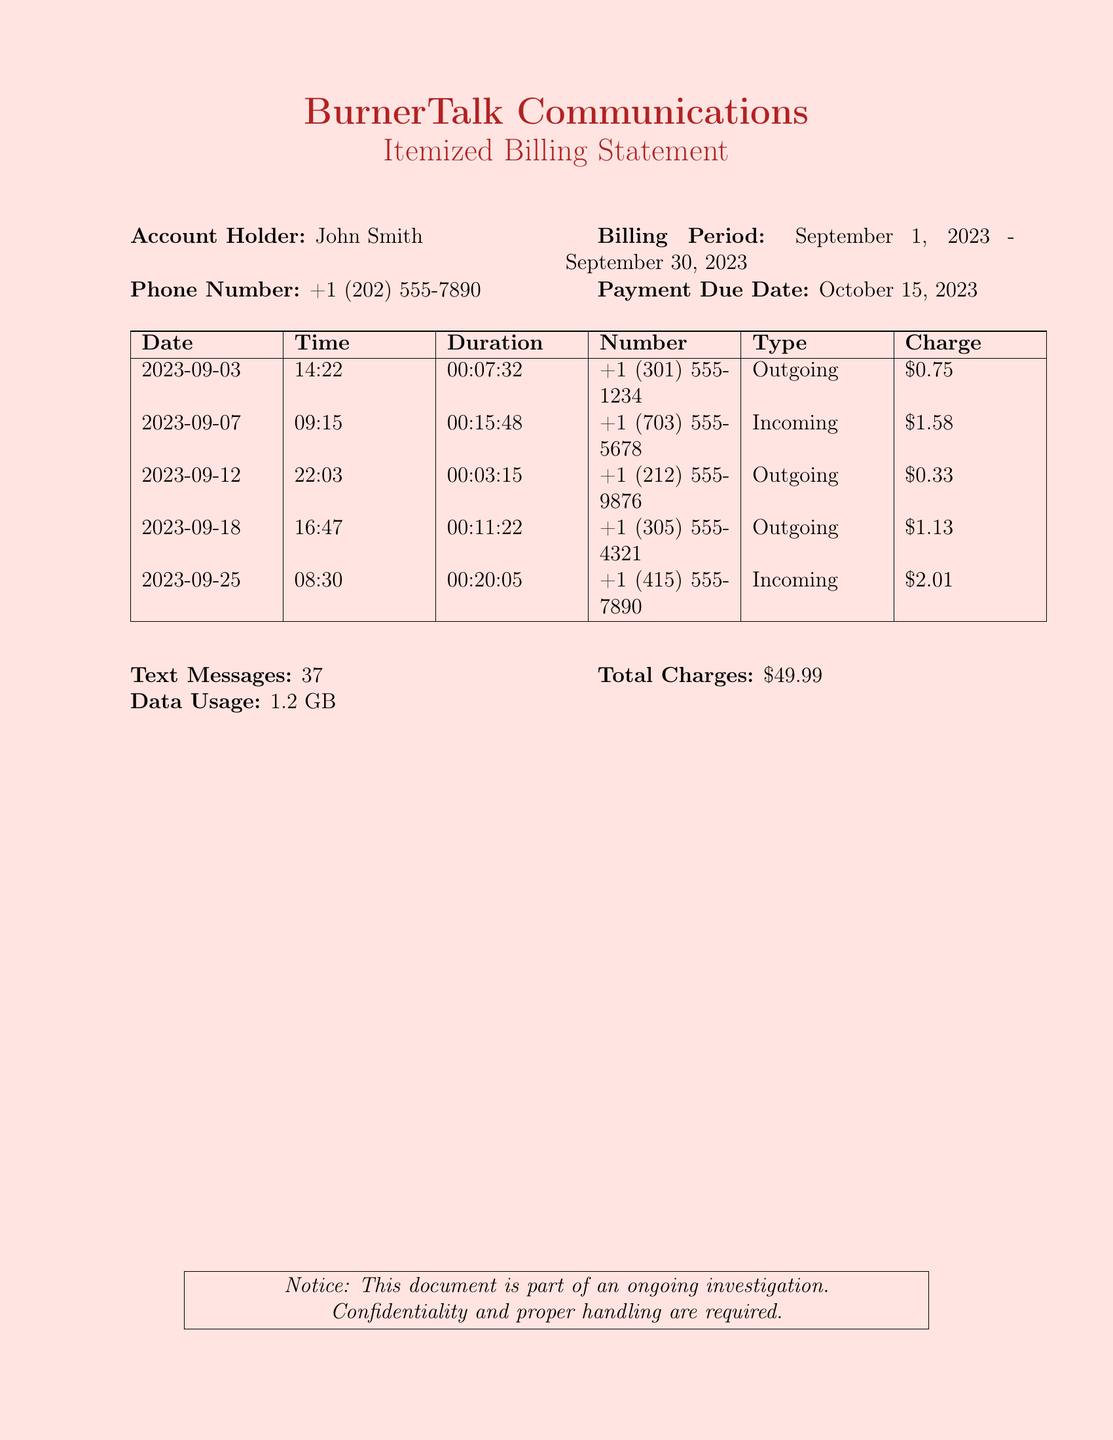What is the account holder's name? The account holder is explicitly stated in the document, which is John Smith.
Answer: John Smith What is the phone number listed? The phone number is clearly mentioned in the document as +1 (202) 555-7890.
Answer: +1 (202) 555-7890 What is the total number of text messages? The document provides the total count of text messages, which is 37.
Answer: 37 What was the charge for the outgoing call on September 12? The document specifies the charge for the call made on September 12, which is $0.33.
Answer: $0.33 How many total charges are listed? The document provides the overall total charges accumulated during the billing period, which is $49.99.
Answer: $49.99 What type of call was made on September 18? The document indicates the type of call made on September 18, which is outgoing.
Answer: Outgoing Which number received the incoming call on September 25? The document lists the number for the incoming call on September 25 as +1 (415) 555-7890.
Answer: +1 (415) 555-7890 What is the duration of the incoming call on September 7? The document states the duration of the incoming call on September 7 was 00:15:48.
Answer: 00:15:48 What is the payment due date? The document clearly notes the payment due date as October 15, 2023.
Answer: October 15, 2023 